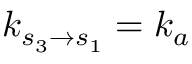<formula> <loc_0><loc_0><loc_500><loc_500>k _ { s _ { 3 } \to s _ { 1 } } = k _ { a }</formula> 